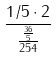Convert formula to latex. <formula><loc_0><loc_0><loc_500><loc_500>\frac { 1 / 5 \cdot 2 } { \frac { \frac { 3 6 } { 5 } } { 2 5 4 } }</formula> 